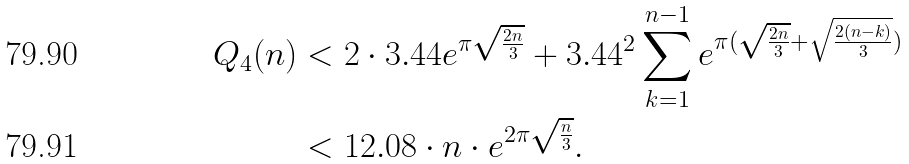Convert formula to latex. <formula><loc_0><loc_0><loc_500><loc_500>Q _ { 4 } ( n ) & < 2 \cdot 3 . 4 4 e ^ { \pi \sqrt { \frac { 2 n } { 3 } } } + 3 . 4 4 ^ { 2 } \sum _ { k = 1 } ^ { n - 1 } e ^ { \pi ( \sqrt { \frac { 2 n } { 3 } } + \sqrt { \frac { 2 ( n - k ) } { 3 } } ) } \\ & < 1 2 . 0 8 \cdot n \cdot e ^ { 2 \pi \sqrt { \frac { n } { 3 } } } .</formula> 